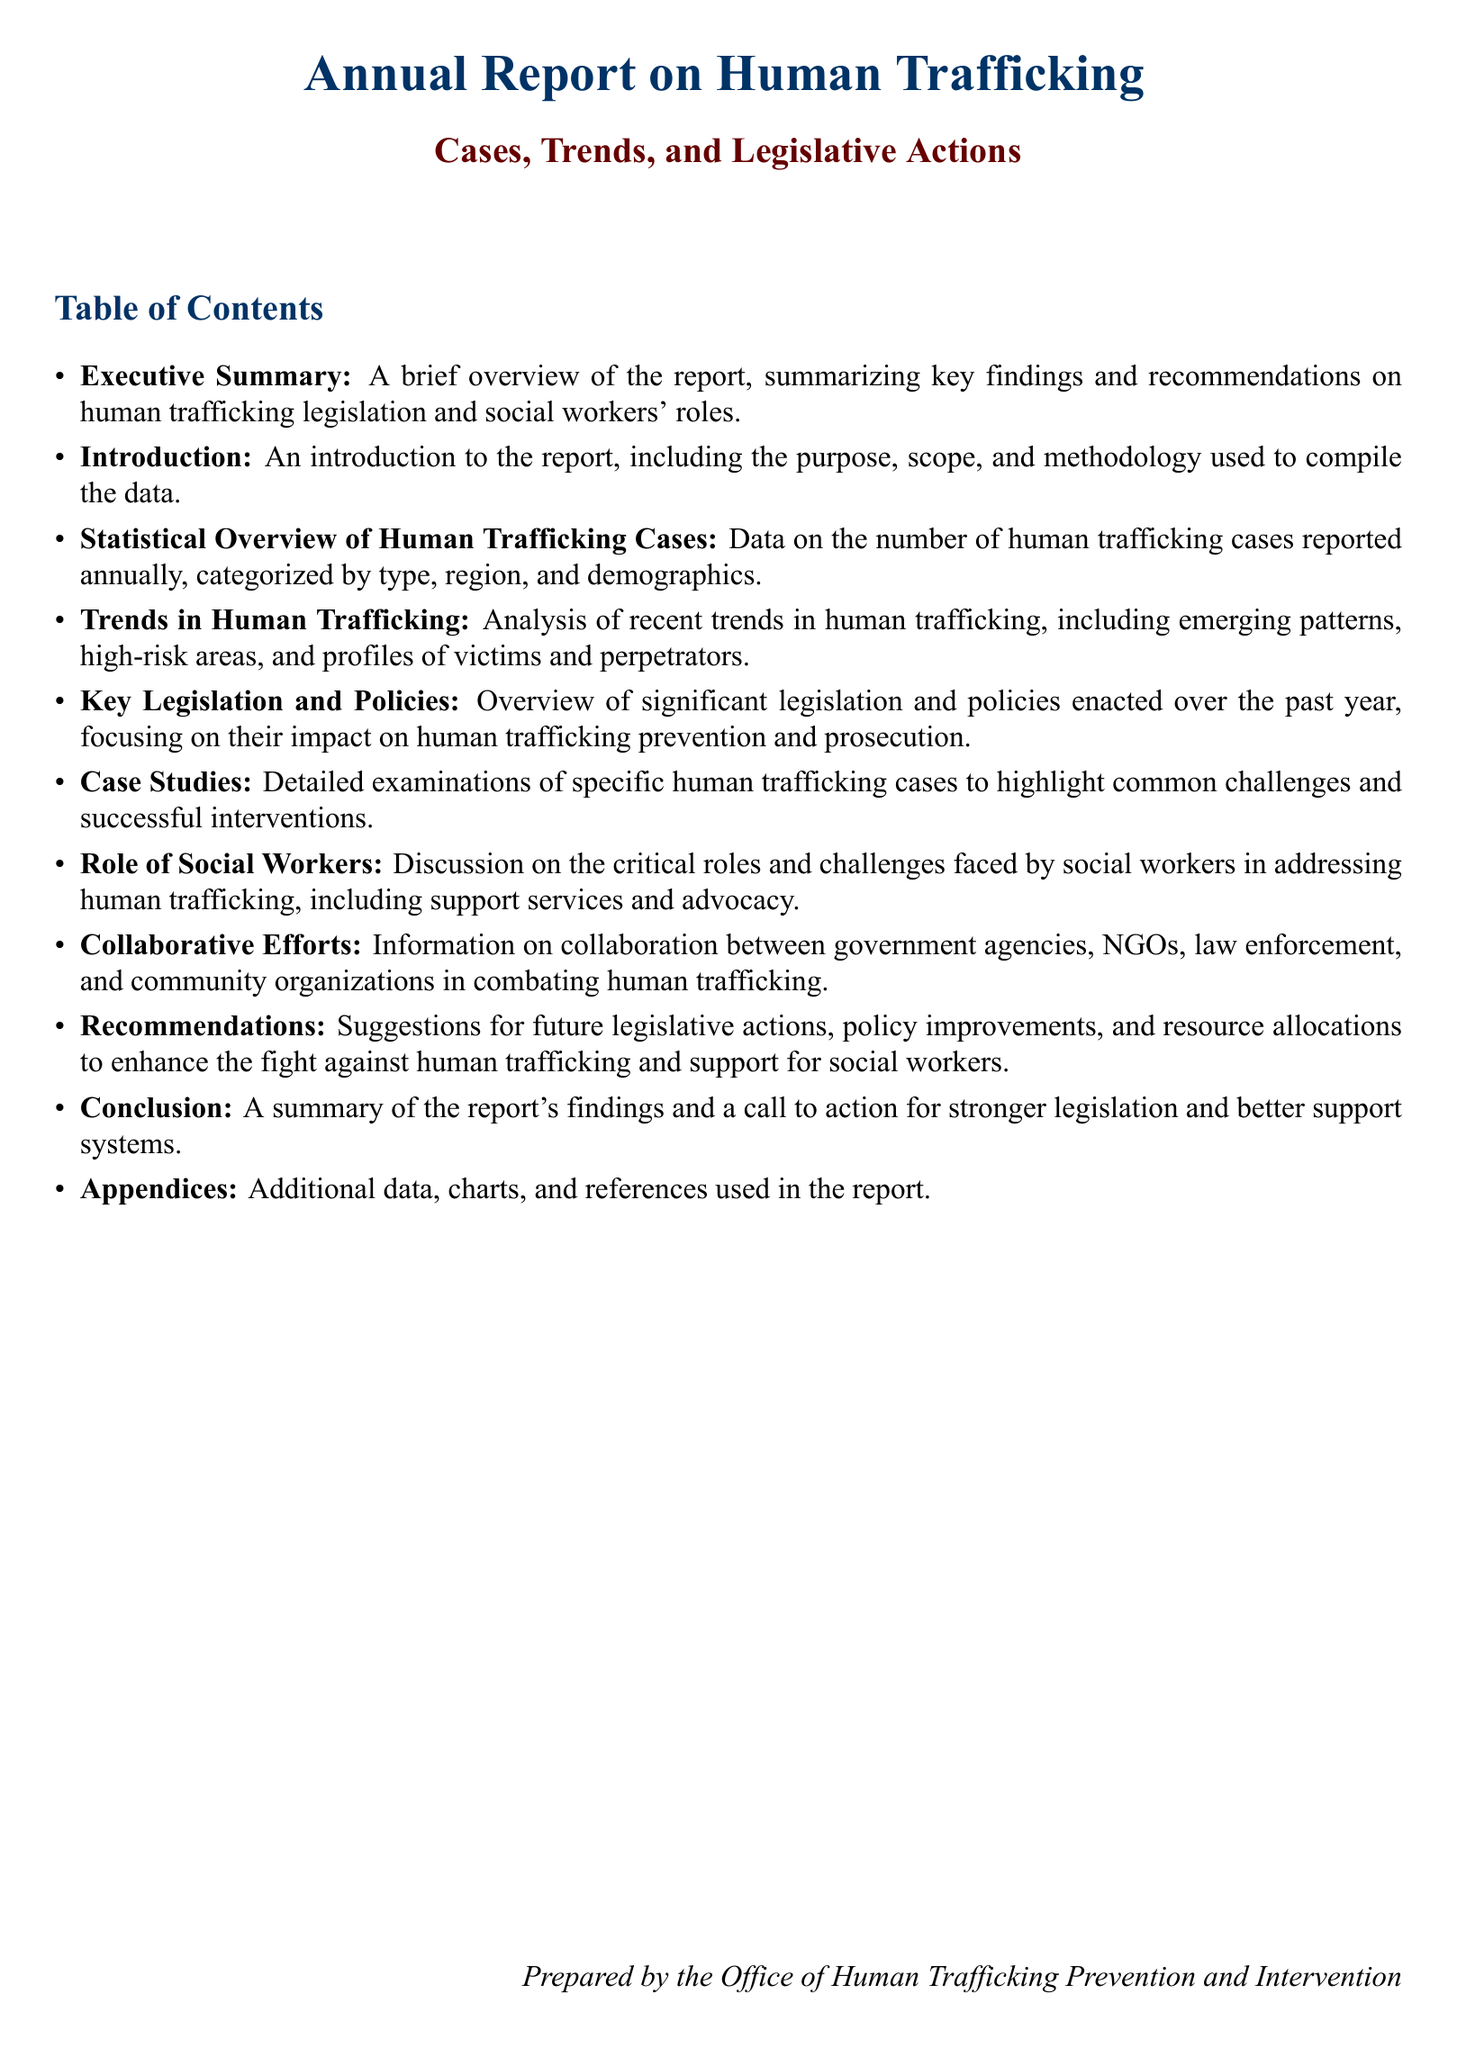What is the purpose of the report? The purpose of the report is to provide insights on human trafficking cases, trends, and legislative actions.
Answer: Insights on human trafficking cases, trends, and legislative actions How many sections are in the Table of Contents? The Table of Contents lists ten main sections.
Answer: Ten What does the 'Role of Social Workers' section discuss? This section discusses the critical roles and challenges faced by social workers in addressing human trafficking.
Answer: Critical roles and challenges faced by social workers What is the focus of the 'Key Legislation and Policies' section? The focus is on significant legislation and policies enacted over the past year and their impact on human trafficking.
Answer: Significant legislation and policies enacted over the past year What type of data is included in the 'Statistical Overview of Human Trafficking Cases'? This section includes data on the number of human trafficking cases reported annually, categorized by various factors.
Answer: Number of human trafficking cases reported annually What is a key recommendation in the report? Suggestions for future legislative actions and policy improvements are provided.
Answer: Future legislative actions and policy improvements 